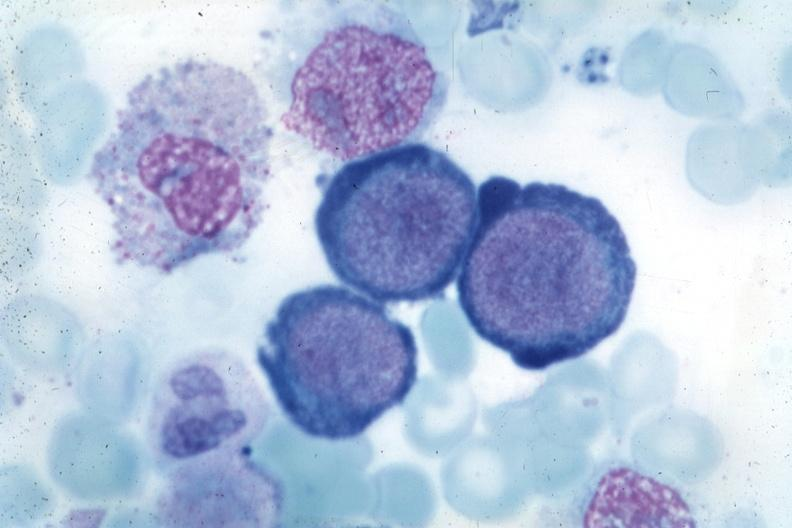does large cell lymphoma show wrights typical cells?
Answer the question using a single word or phrase. No 